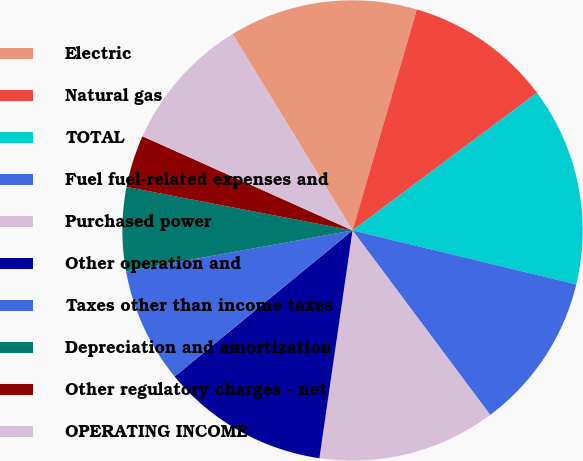Convert chart to OTSL. <chart><loc_0><loc_0><loc_500><loc_500><pie_chart><fcel>Electric<fcel>Natural gas<fcel>TOTAL<fcel>Fuel fuel-related expenses and<fcel>Purchased power<fcel>Other operation and<fcel>Taxes other than income taxes<fcel>Depreciation and amortization<fcel>Other regulatory charges - net<fcel>OPERATING INCOME<nl><fcel>13.24%<fcel>10.29%<fcel>13.97%<fcel>11.03%<fcel>12.5%<fcel>11.76%<fcel>8.09%<fcel>5.88%<fcel>3.68%<fcel>9.56%<nl></chart> 